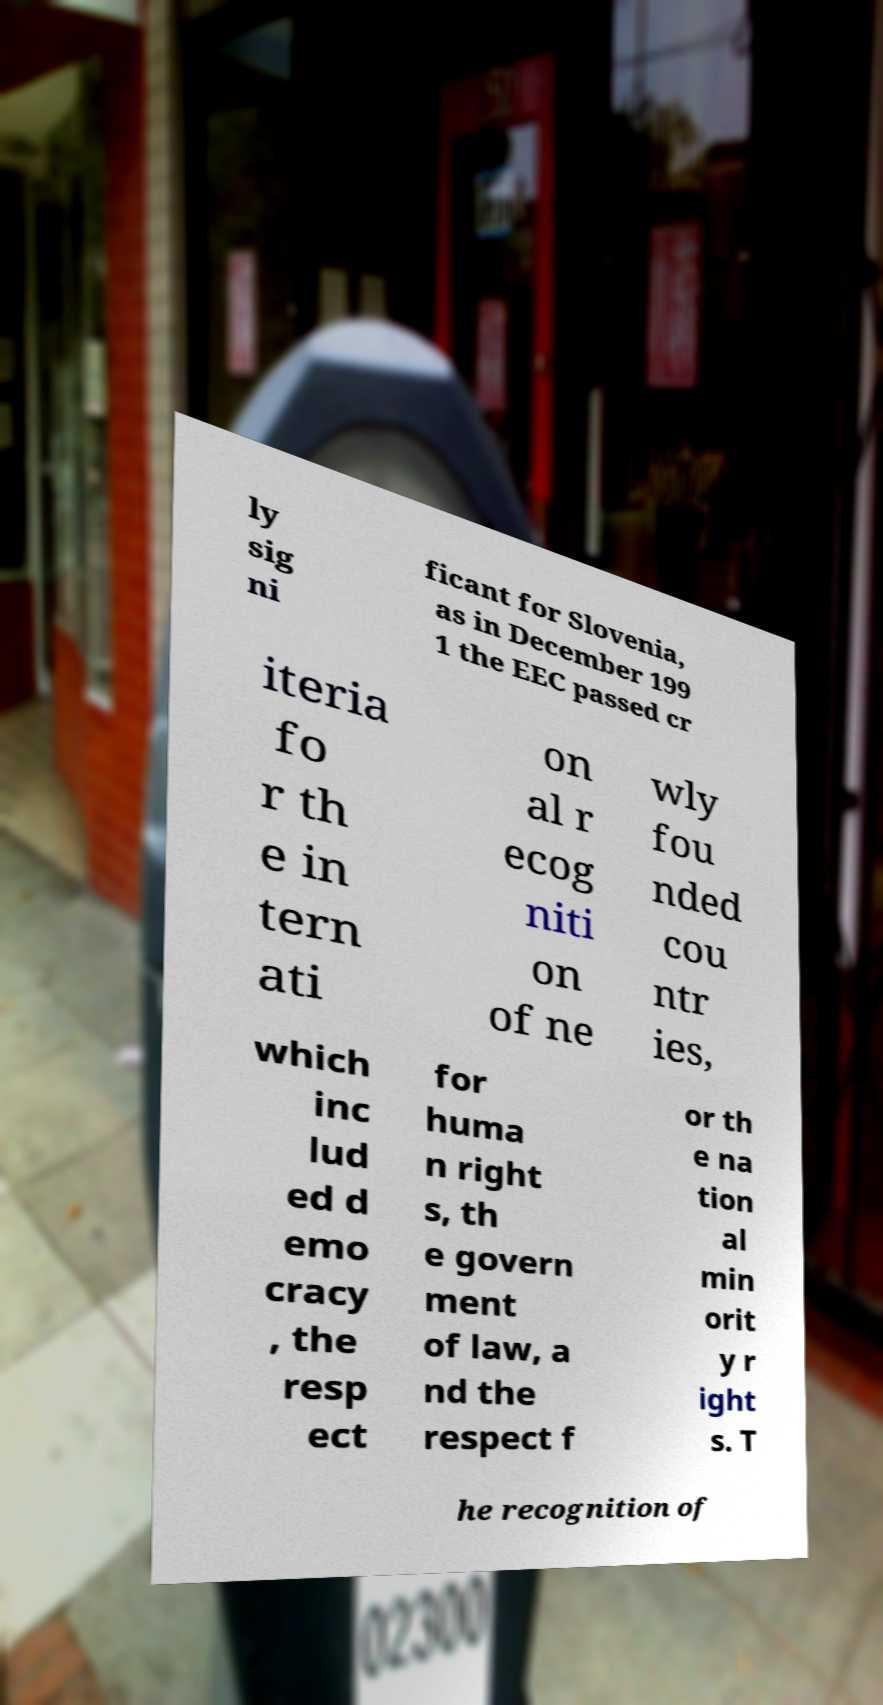There's text embedded in this image that I need extracted. Can you transcribe it verbatim? ly sig ni ficant for Slovenia, as in December 199 1 the EEC passed cr iteria fo r th e in tern ati on al r ecog niti on of ne wly fou nded cou ntr ies, which inc lud ed d emo cracy , the resp ect for huma n right s, th e govern ment of law, a nd the respect f or th e na tion al min orit y r ight s. T he recognition of 